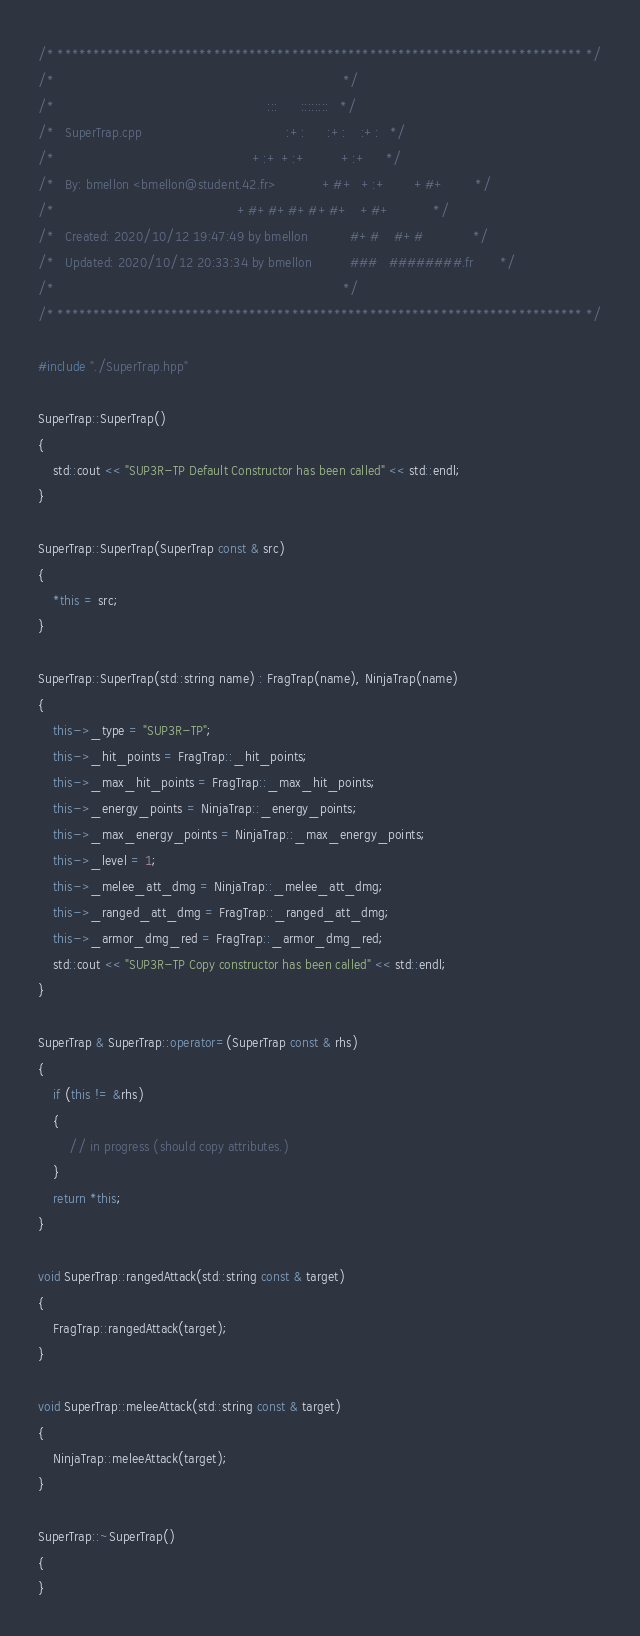Convert code to text. <code><loc_0><loc_0><loc_500><loc_500><_C++_>/* ************************************************************************** */
/*                                                                            */
/*                                                        :::      ::::::::   */
/*   SuperTrap.cpp                                      :+:      :+:    :+:   */
/*                                                    +:+ +:+         +:+     */
/*   By: bmellon <bmellon@student.42.fr>            +#+  +:+       +#+        */
/*                                                +#+#+#+#+#+   +#+           */
/*   Created: 2020/10/12 19:47:49 by bmellon           #+#    #+#             */
/*   Updated: 2020/10/12 20:33:34 by bmellon          ###   ########.fr       */
/*                                                                            */
/* ************************************************************************** */

#include "./SuperTrap.hpp"

SuperTrap::SuperTrap()
{
	std::cout << "SUP3R-TP Default Constructor has been called" << std::endl;
}

SuperTrap::SuperTrap(SuperTrap const & src)
{
	*this = src;
}

SuperTrap::SuperTrap(std::string name) : FragTrap(name), NinjaTrap(name)
{
	this->_type = "SUP3R-TP";
	this->_hit_points = FragTrap::_hit_points;
	this->_max_hit_points = FragTrap::_max_hit_points;
	this->_energy_points = NinjaTrap::_energy_points;
	this->_max_energy_points = NinjaTrap::_max_energy_points;
	this->_level = 1;
	this->_melee_att_dmg = NinjaTrap::_melee_att_dmg;
	this->_ranged_att_dmg = FragTrap::_ranged_att_dmg;
	this->_armor_dmg_red = FragTrap::_armor_dmg_red;
	std::cout << "SUP3R-TP Copy constructor has been called" << std::endl;
}

SuperTrap & SuperTrap::operator=(SuperTrap const & rhs)
{
	if (this != &rhs)
	{
		// in progress (should copy attributes.)
	}
	return *this;
}

void SuperTrap::rangedAttack(std::string const & target)
{
	FragTrap::rangedAttack(target);
}

void SuperTrap::meleeAttack(std::string const & target)
{
	NinjaTrap::meleeAttack(target);
}

SuperTrap::~SuperTrap()
{
}

</code> 